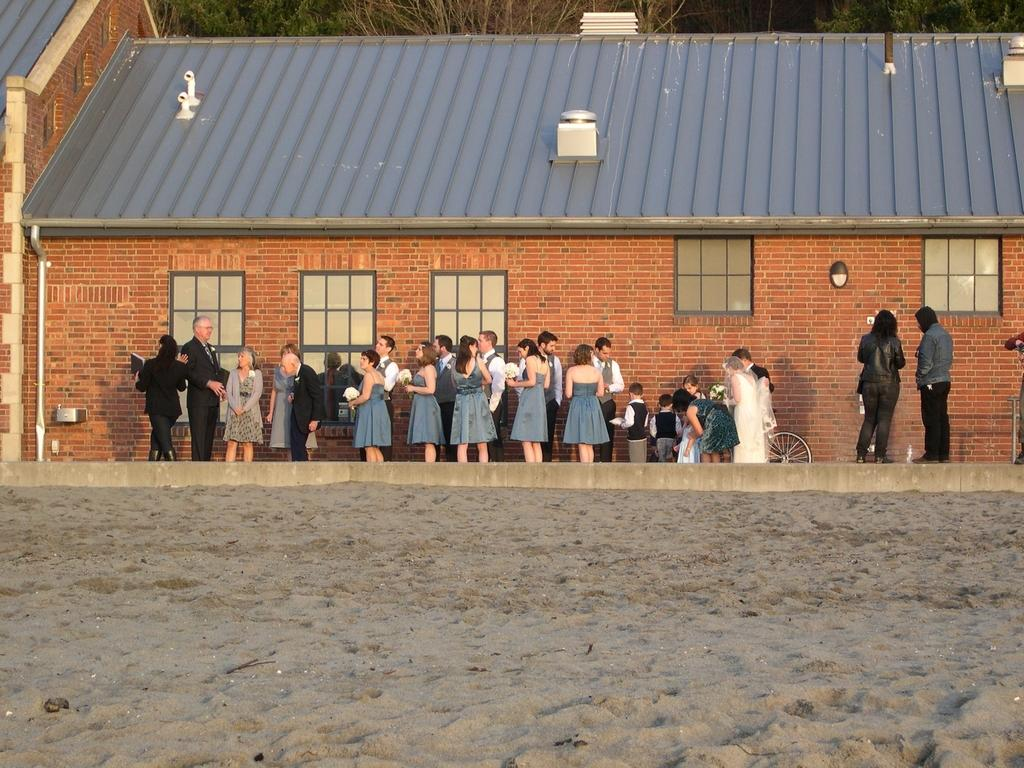What type of surface is visible in the image? There is sand visible in the image. Who or what can be seen in the image? There are people in the image. What type of structure is present in the image? There is a wall in the image. Are there any openings in the wall? Yes, there are windows in the image. What is the highest point of the structure in the image? There is a roof top in the image. What can be seen in the background of the image? Trees are present in the background of the image. How many ice cubes are on the roof top in the image? There is no ice or ice cubes present on the roof top in the image. 